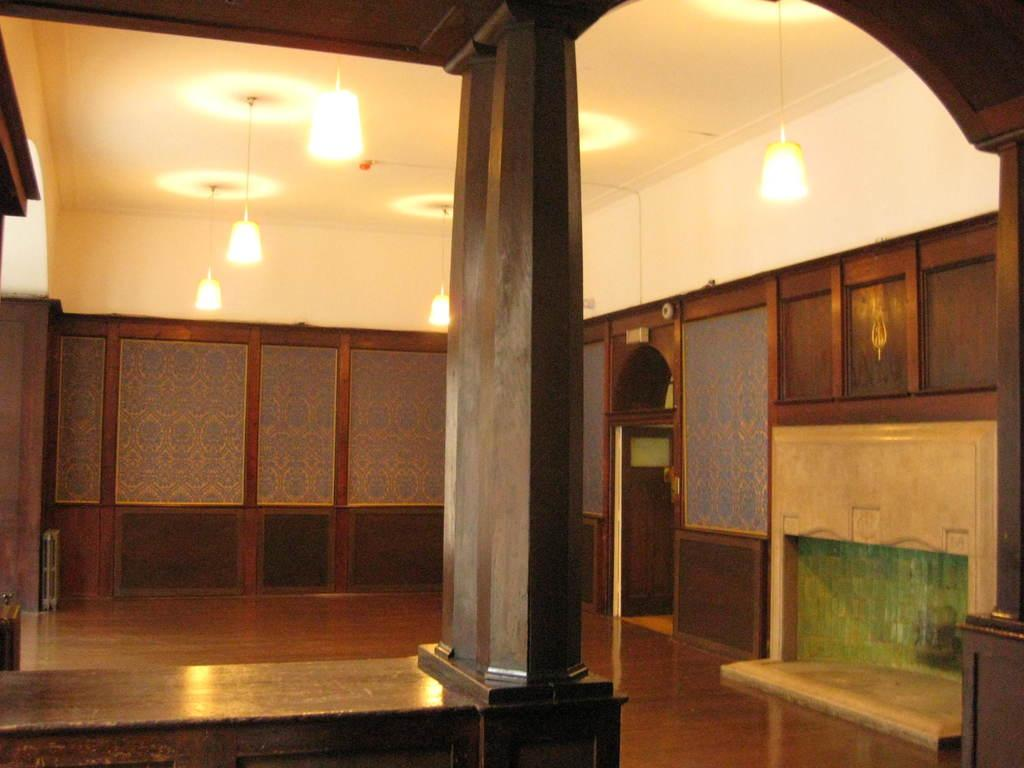What type of space is shown in the image? The image shows an inside view of a room. What can be seen in the room? There are lights visible in the room. What part of the room is visible at the top of the image? The ceiling is visible at the top of the image. What type of picture is hanging on the wall in the image? There is no picture hanging on the wall in the image; only lights and the ceiling are visible. 